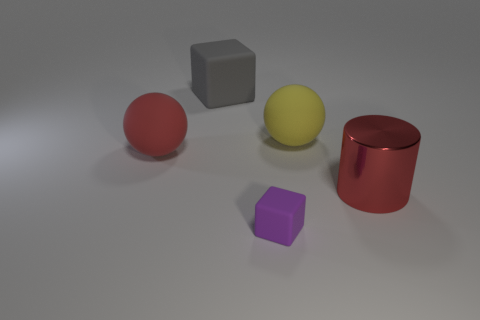Subtract all gray cubes. Subtract all yellow cylinders. How many cubes are left? 1 Add 5 yellow matte objects. How many objects exist? 10 Subtract all spheres. How many objects are left? 3 Subtract all large rubber spheres. Subtract all red rubber objects. How many objects are left? 2 Add 1 metallic things. How many metallic things are left? 2 Add 5 yellow matte things. How many yellow matte things exist? 6 Subtract 1 red cylinders. How many objects are left? 4 